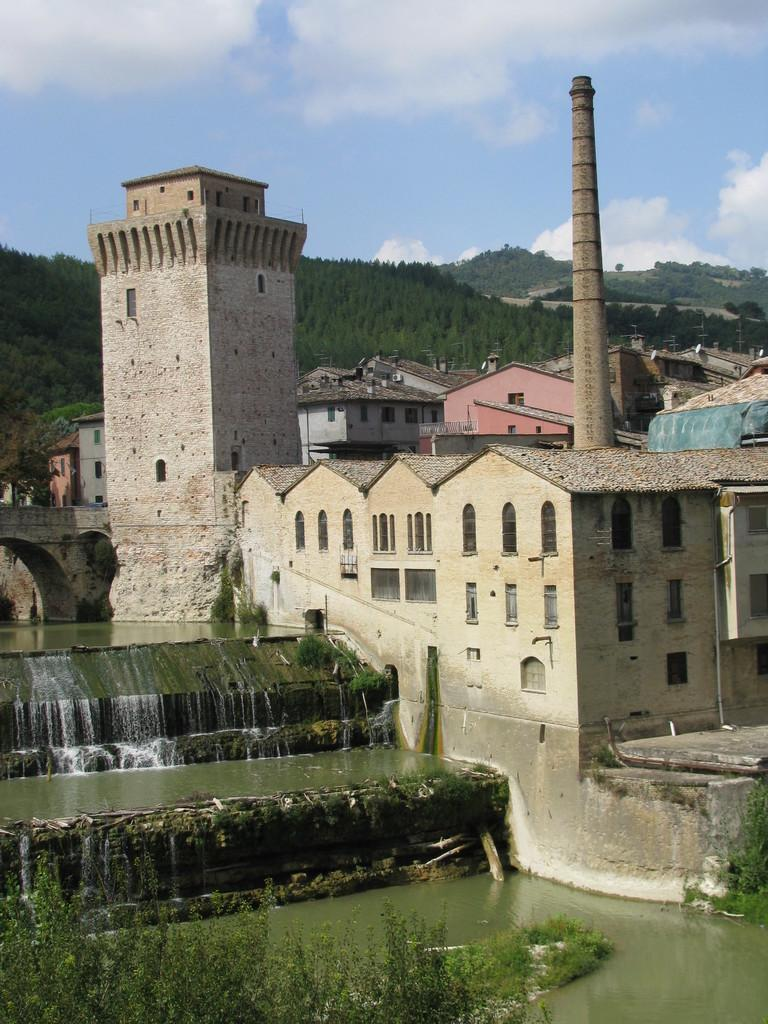What is one of the natural elements present in the image? There is water in the image. What type of vegetation can be seen in the image? There are trees in the image. What type of structures are present in the image? There are stone houses in the image. What architectural feature is present in the image? There is a bridge in the image. What type of landscape can be seen in the image? There are hills with trees in the image. How would you describe the weather in the image? The sky in the background is cloudy, suggesting a potentially overcast or rainy day. Can you tell me how many family members are visible in the image? There is no family present in the image; it features a landscape with water, trees, stone houses, a bridge, hills with trees, and a cloudy sky. What type of beast is leading the group of people in the image? There are no people or beasts present in the image; it features a landscape with water, trees, stone houses, a bridge, hills with trees, and a cloudy sky. 